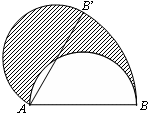How can you calculate the area of the shaded region? To calculate the area of the shaded region, which is a segment of the semicircle, you would first calculate the area of sector ABB'. This can be done by determining the angle at A, which the lines AB and AB' form. If the angle is \\theta radians, then the area of the sector is \\frac{1}{2} \\times r^2 \\times \\theta, where r is the radius of the semicircle. To find the area of the segment, subtract the area of triangle ABB' from the area of sector ABB'. Triangle ABB' can be calculated using basic trigonometric relations if the angle \\theta and segment lengths AB and AB' are known. 